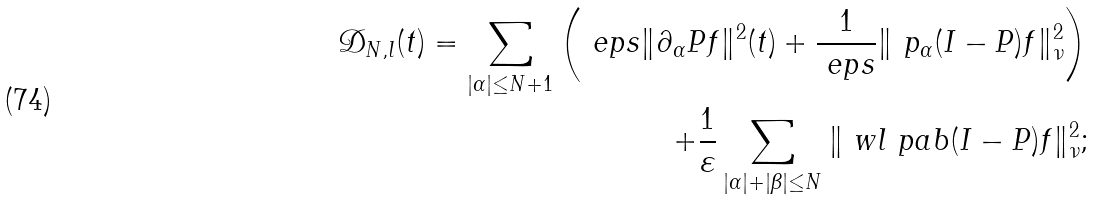<formula> <loc_0><loc_0><loc_500><loc_500>\mathcal { D } _ { N , l } ( t ) = \sum _ { | \alpha | \leq N + 1 } \left ( \ e p s \| \partial _ { \alpha } P f \| ^ { 2 } ( t ) + \frac { 1 } { \ e p s } \| \ p _ { \alpha } ( I - P ) f \| ^ { 2 } _ { \nu } \right ) \\ + \frac { 1 } { \varepsilon } \sum _ { | \alpha | + | \beta | \leq N } \| \ w l \ p a b ( I - P ) f \| _ { \nu } ^ { 2 } ;</formula> 